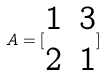Convert formula to latex. <formula><loc_0><loc_0><loc_500><loc_500>A = [ \begin{matrix} 1 & 3 \\ 2 & 1 \end{matrix} ]</formula> 